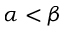Convert formula to latex. <formula><loc_0><loc_0><loc_500><loc_500>\alpha < \beta</formula> 